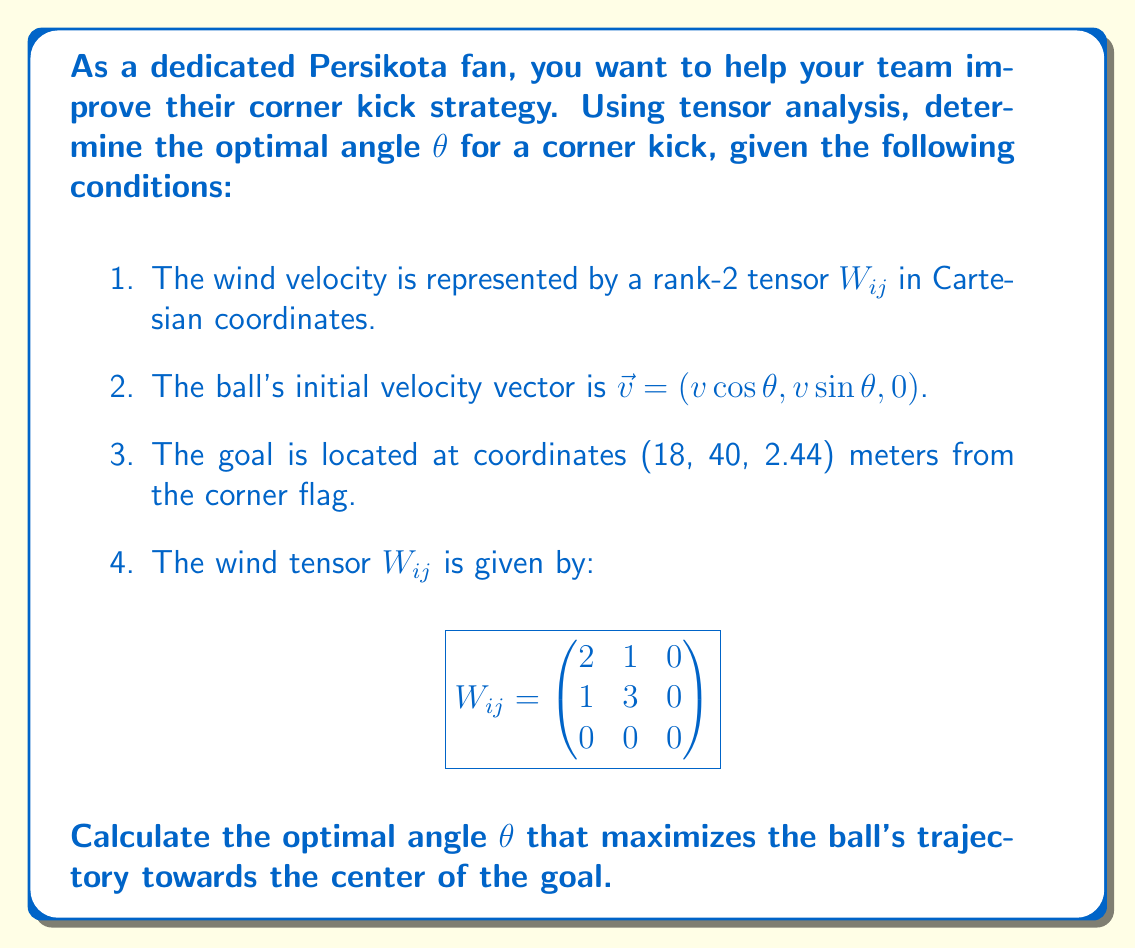Show me your answer to this math problem. Let's approach this problem step-by-step using tensor analysis:

1) First, we need to consider the effect of the wind on the ball's trajectory. The wind tensor $W_{ij}$ represents the wind's influence in different directions.

2) The force exerted by the wind on the ball can be represented as:

   $F_i = W_{ij}v_j$

   where $v_j$ is the ball's velocity vector.

3) Expanding this equation:

   $$\begin{pmatrix}
   F_x \\
   F_y \\
   F_z
   \end{pmatrix} = \begin{pmatrix}
   2 & 1 & 0 \\
   1 & 3 & 0 \\
   0 & 0 & 0
   \end{pmatrix} \begin{pmatrix}
   v \cos θ \\
   v \sin θ \\
   0
   \end{pmatrix}$$

4) Calculating the components:

   $F_x = 2v \cos θ + v \sin θ$
   $F_y = v \cos θ + 3v \sin θ$
   $F_z = 0$

5) The optimal angle will maximize the ball's movement towards the goal. We can represent this as maximizing the dot product of the force vector with a unit vector pointing towards the goal.

6) The unit vector pointing towards the goal is:

   $\hat{u} = \frac{(18, 40, 2.44)}{\sqrt{18^2 + 40^2 + 2.44^2}} \approx (0.4096, 0.9102, 0.0555)$

7) We want to maximize:

   $F \cdot \hat{u} = F_x(0.4096) + F_y(0.9102) + F_z(0.0555)$

8) Substituting the force components:

   $F \cdot \hat{u} = (2v \cos θ + v \sin θ)(0.4096) + (v \cos θ + 3v \sin θ)(0.9102)$

9) Simplifying:

   $F \cdot \hat{u} = v(0.8192 \cos θ + 0.4096 \sin θ + 0.9102 \cos θ + 2.7306 \sin θ)$
   $F \cdot \hat{u} = v(1.7294 \cos θ + 3.1402 \sin θ)$

10) To maximize this, we set its derivative with respect to θ to zero:

    $\frac{d}{dθ}(F \cdot \hat{u}) = v(-1.7294 \sin θ + 3.1402 \cos θ) = 0$

11) Solving this equation:

    $\tan θ = \frac{3.1402}{1.7294} \approx 1.8158$

12) Taking the inverse tangent:

    $θ = \arctan(1.8158) \approx 1.0684$ radians or $61.2°$

This angle maximizes the effect of the wind in propelling the ball towards the goal.
Answer: $θ \approx 61.2°$ 